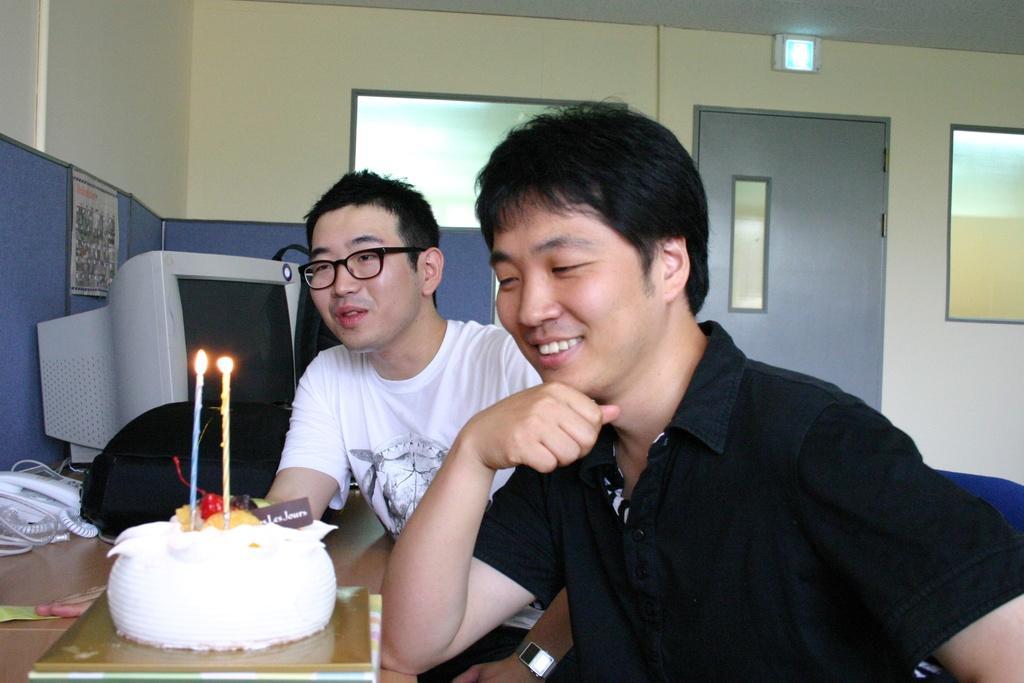Can you describe this image briefly? In this image we can see two men sitting on the chairs beside a table containing a cake in a plate with some candles on it, a telephone with some wires, a bag and a monitor which are placed on it. On the backside we can see a door, windows, a banner on a wall, a signboard and a roof. 